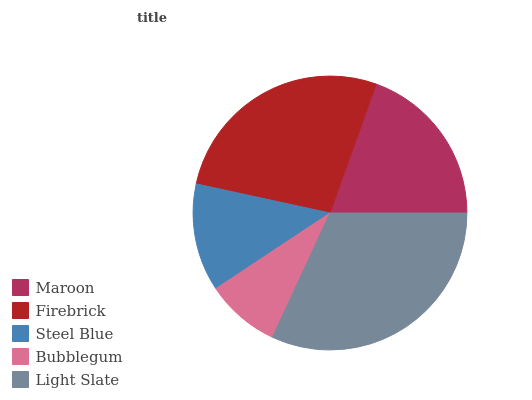Is Bubblegum the minimum?
Answer yes or no. Yes. Is Light Slate the maximum?
Answer yes or no. Yes. Is Firebrick the minimum?
Answer yes or no. No. Is Firebrick the maximum?
Answer yes or no. No. Is Firebrick greater than Maroon?
Answer yes or no. Yes. Is Maroon less than Firebrick?
Answer yes or no. Yes. Is Maroon greater than Firebrick?
Answer yes or no. No. Is Firebrick less than Maroon?
Answer yes or no. No. Is Maroon the high median?
Answer yes or no. Yes. Is Maroon the low median?
Answer yes or no. Yes. Is Steel Blue the high median?
Answer yes or no. No. Is Bubblegum the low median?
Answer yes or no. No. 